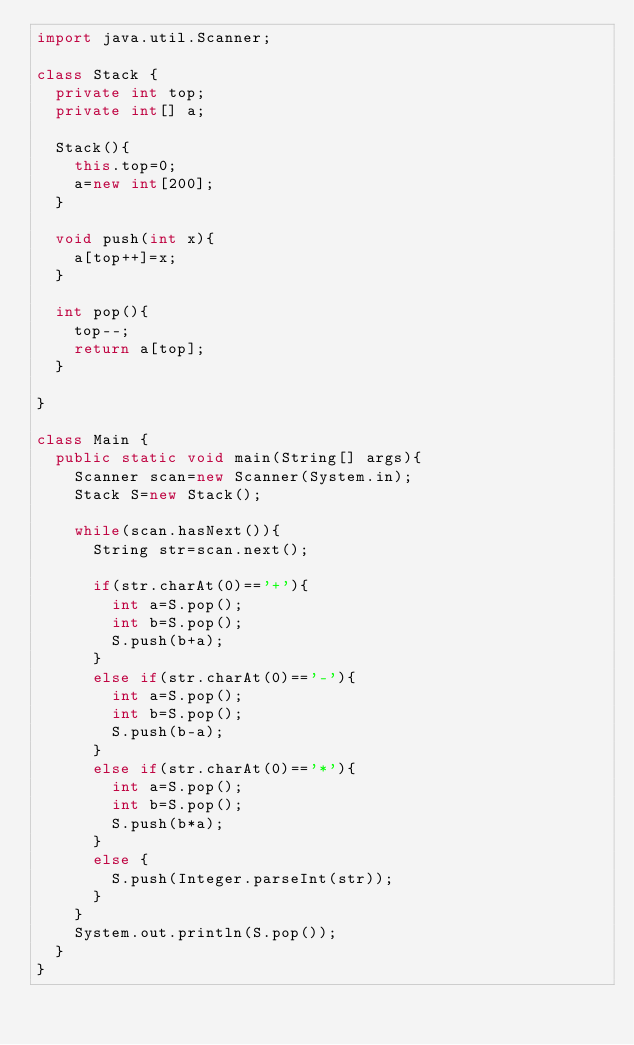<code> <loc_0><loc_0><loc_500><loc_500><_Java_>import java.util.Scanner;

class Stack {
	private int top;
	private int[] a;
	
	Stack(){
		this.top=0;
		a=new int[200];
	}
	
	void push(int x){
		a[top++]=x;
	}
	
	int pop(){
		top--;
		return a[top];
	}
	
}

class Main {
	public static void main(String[] args){
		Scanner scan=new Scanner(System.in);
		Stack S=new Stack();
		
		while(scan.hasNext()){
			String str=scan.next();

			if(str.charAt(0)=='+'){
				int a=S.pop();
				int b=S.pop();
				S.push(b+a);
			}
			else if(str.charAt(0)=='-'){
				int a=S.pop();
				int b=S.pop();
				S.push(b-a);
			}
			else if(str.charAt(0)=='*'){
				int a=S.pop();
				int b=S.pop();
				S.push(b*a);
			}
			else {
				S.push(Integer.parseInt(str));
			}
		}
		System.out.println(S.pop());
	}
}
</code> 